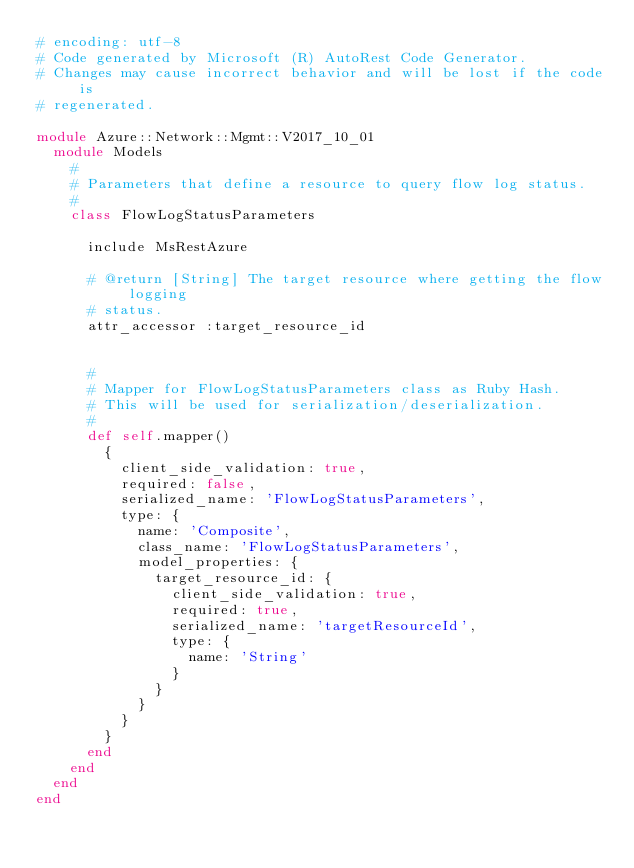<code> <loc_0><loc_0><loc_500><loc_500><_Ruby_># encoding: utf-8
# Code generated by Microsoft (R) AutoRest Code Generator.
# Changes may cause incorrect behavior and will be lost if the code is
# regenerated.

module Azure::Network::Mgmt::V2017_10_01
  module Models
    #
    # Parameters that define a resource to query flow log status.
    #
    class FlowLogStatusParameters

      include MsRestAzure

      # @return [String] The target resource where getting the flow logging
      # status.
      attr_accessor :target_resource_id


      #
      # Mapper for FlowLogStatusParameters class as Ruby Hash.
      # This will be used for serialization/deserialization.
      #
      def self.mapper()
        {
          client_side_validation: true,
          required: false,
          serialized_name: 'FlowLogStatusParameters',
          type: {
            name: 'Composite',
            class_name: 'FlowLogStatusParameters',
            model_properties: {
              target_resource_id: {
                client_side_validation: true,
                required: true,
                serialized_name: 'targetResourceId',
                type: {
                  name: 'String'
                }
              }
            }
          }
        }
      end
    end
  end
end
</code> 